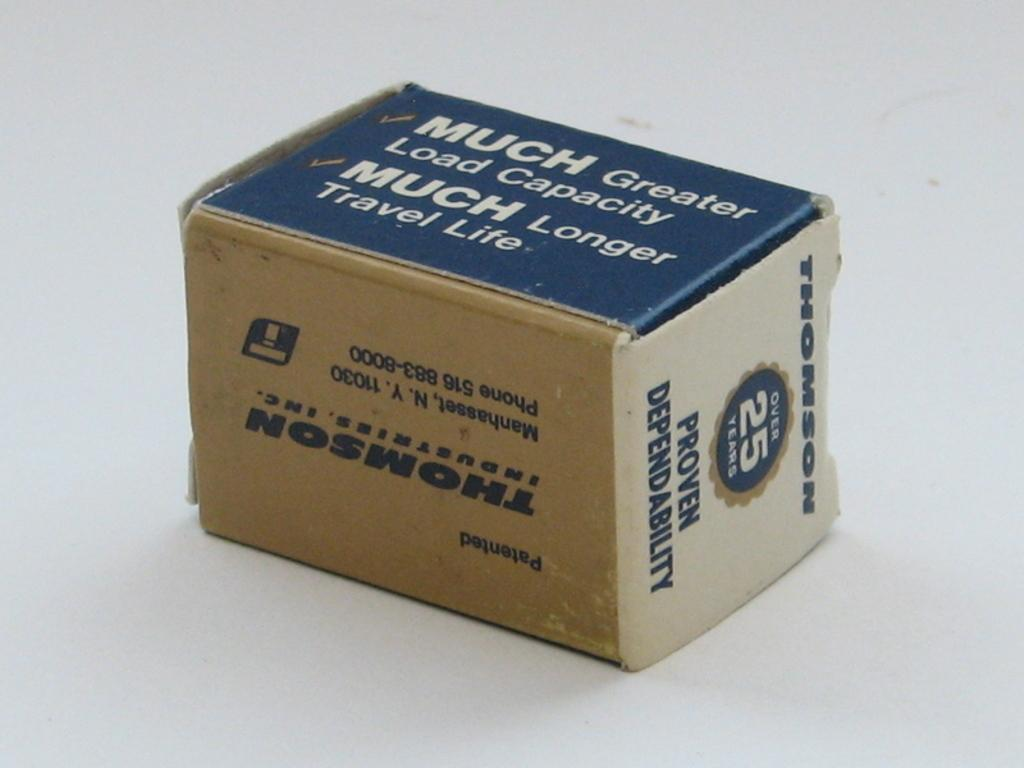<image>
Offer a succinct explanation of the picture presented. Small blue and brown box that says Much Greater Load Capacity. 